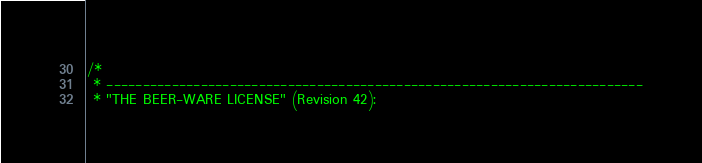<code> <loc_0><loc_0><loc_500><loc_500><_C++_>/*
 * --------------------------------------------------------------------------
 * "THE BEER-WARE LICENSE" (Revision 42):</code> 